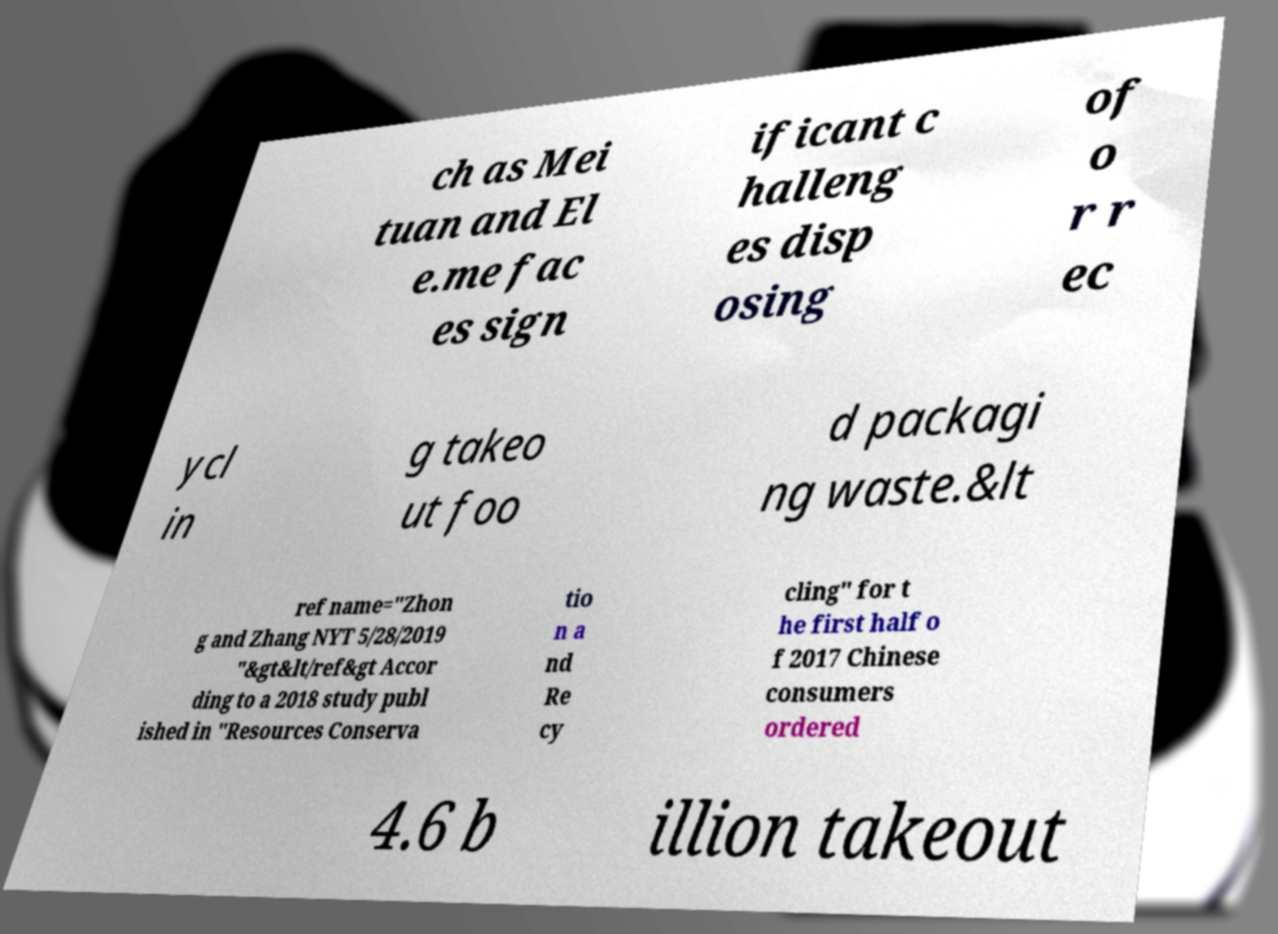Could you assist in decoding the text presented in this image and type it out clearly? ch as Mei tuan and El e.me fac es sign ificant c halleng es disp osing of o r r ec ycl in g takeo ut foo d packagi ng waste.&lt ref name="Zhon g and Zhang NYT 5/28/2019 "&gt&lt/ref&gt Accor ding to a 2018 study publ ished in "Resources Conserva tio n a nd Re cy cling" for t he first half o f 2017 Chinese consumers ordered 4.6 b illion takeout 